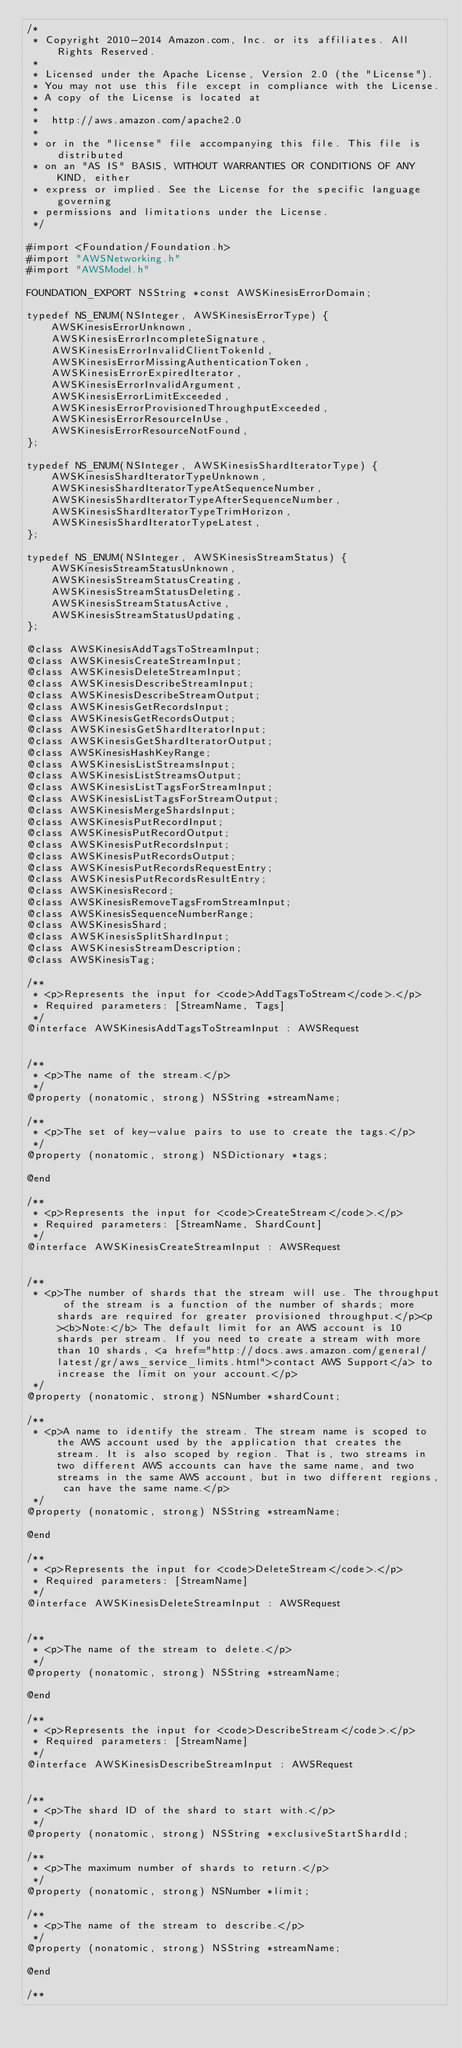<code> <loc_0><loc_0><loc_500><loc_500><_C_>/*
 * Copyright 2010-2014 Amazon.com, Inc. or its affiliates. All Rights Reserved.
 *
 * Licensed under the Apache License, Version 2.0 (the "License").
 * You may not use this file except in compliance with the License.
 * A copy of the License is located at
 *
 *  http://aws.amazon.com/apache2.0
 *
 * or in the "license" file accompanying this file. This file is distributed
 * on an "AS IS" BASIS, WITHOUT WARRANTIES OR CONDITIONS OF ANY KIND, either
 * express or implied. See the License for the specific language governing
 * permissions and limitations under the License.
 */

#import <Foundation/Foundation.h>
#import "AWSNetworking.h"
#import "AWSModel.h"

FOUNDATION_EXPORT NSString *const AWSKinesisErrorDomain;

typedef NS_ENUM(NSInteger, AWSKinesisErrorType) {
    AWSKinesisErrorUnknown,
    AWSKinesisErrorIncompleteSignature,
    AWSKinesisErrorInvalidClientTokenId,
    AWSKinesisErrorMissingAuthenticationToken,
    AWSKinesisErrorExpiredIterator,
    AWSKinesisErrorInvalidArgument,
    AWSKinesisErrorLimitExceeded,
    AWSKinesisErrorProvisionedThroughputExceeded,
    AWSKinesisErrorResourceInUse,
    AWSKinesisErrorResourceNotFound,
};

typedef NS_ENUM(NSInteger, AWSKinesisShardIteratorType) {
    AWSKinesisShardIteratorTypeUnknown,
    AWSKinesisShardIteratorTypeAtSequenceNumber,
    AWSKinesisShardIteratorTypeAfterSequenceNumber,
    AWSKinesisShardIteratorTypeTrimHorizon,
    AWSKinesisShardIteratorTypeLatest,
};

typedef NS_ENUM(NSInteger, AWSKinesisStreamStatus) {
    AWSKinesisStreamStatusUnknown,
    AWSKinesisStreamStatusCreating,
    AWSKinesisStreamStatusDeleting,
    AWSKinesisStreamStatusActive,
    AWSKinesisStreamStatusUpdating,
};

@class AWSKinesisAddTagsToStreamInput;
@class AWSKinesisCreateStreamInput;
@class AWSKinesisDeleteStreamInput;
@class AWSKinesisDescribeStreamInput;
@class AWSKinesisDescribeStreamOutput;
@class AWSKinesisGetRecordsInput;
@class AWSKinesisGetRecordsOutput;
@class AWSKinesisGetShardIteratorInput;
@class AWSKinesisGetShardIteratorOutput;
@class AWSKinesisHashKeyRange;
@class AWSKinesisListStreamsInput;
@class AWSKinesisListStreamsOutput;
@class AWSKinesisListTagsForStreamInput;
@class AWSKinesisListTagsForStreamOutput;
@class AWSKinesisMergeShardsInput;
@class AWSKinesisPutRecordInput;
@class AWSKinesisPutRecordOutput;
@class AWSKinesisPutRecordsInput;
@class AWSKinesisPutRecordsOutput;
@class AWSKinesisPutRecordsRequestEntry;
@class AWSKinesisPutRecordsResultEntry;
@class AWSKinesisRecord;
@class AWSKinesisRemoveTagsFromStreamInput;
@class AWSKinesisSequenceNumberRange;
@class AWSKinesisShard;
@class AWSKinesisSplitShardInput;
@class AWSKinesisStreamDescription;
@class AWSKinesisTag;

/**
 * <p>Represents the input for <code>AddTagsToStream</code>.</p>
 * Required parameters: [StreamName, Tags]
 */
@interface AWSKinesisAddTagsToStreamInput : AWSRequest


/**
 * <p>The name of the stream.</p>
 */
@property (nonatomic, strong) NSString *streamName;

/**
 * <p>The set of key-value pairs to use to create the tags.</p>
 */
@property (nonatomic, strong) NSDictionary *tags;

@end

/**
 * <p>Represents the input for <code>CreateStream</code>.</p>
 * Required parameters: [StreamName, ShardCount]
 */
@interface AWSKinesisCreateStreamInput : AWSRequest


/**
 * <p>The number of shards that the stream will use. The throughput of the stream is a function of the number of shards; more shards are required for greater provisioned throughput.</p><p><b>Note:</b> The default limit for an AWS account is 10 shards per stream. If you need to create a stream with more than 10 shards, <a href="http://docs.aws.amazon.com/general/latest/gr/aws_service_limits.html">contact AWS Support</a> to increase the limit on your account.</p>
 */
@property (nonatomic, strong) NSNumber *shardCount;

/**
 * <p>A name to identify the stream. The stream name is scoped to the AWS account used by the application that creates the stream. It is also scoped by region. That is, two streams in two different AWS accounts can have the same name, and two streams in the same AWS account, but in two different regions, can have the same name.</p>
 */
@property (nonatomic, strong) NSString *streamName;

@end

/**
 * <p>Represents the input for <code>DeleteStream</code>.</p>
 * Required parameters: [StreamName]
 */
@interface AWSKinesisDeleteStreamInput : AWSRequest


/**
 * <p>The name of the stream to delete.</p>
 */
@property (nonatomic, strong) NSString *streamName;

@end

/**
 * <p>Represents the input for <code>DescribeStream</code>.</p>
 * Required parameters: [StreamName]
 */
@interface AWSKinesisDescribeStreamInput : AWSRequest


/**
 * <p>The shard ID of the shard to start with.</p>
 */
@property (nonatomic, strong) NSString *exclusiveStartShardId;

/**
 * <p>The maximum number of shards to return.</p>
 */
@property (nonatomic, strong) NSNumber *limit;

/**
 * <p>The name of the stream to describe.</p>
 */
@property (nonatomic, strong) NSString *streamName;

@end

/**</code> 